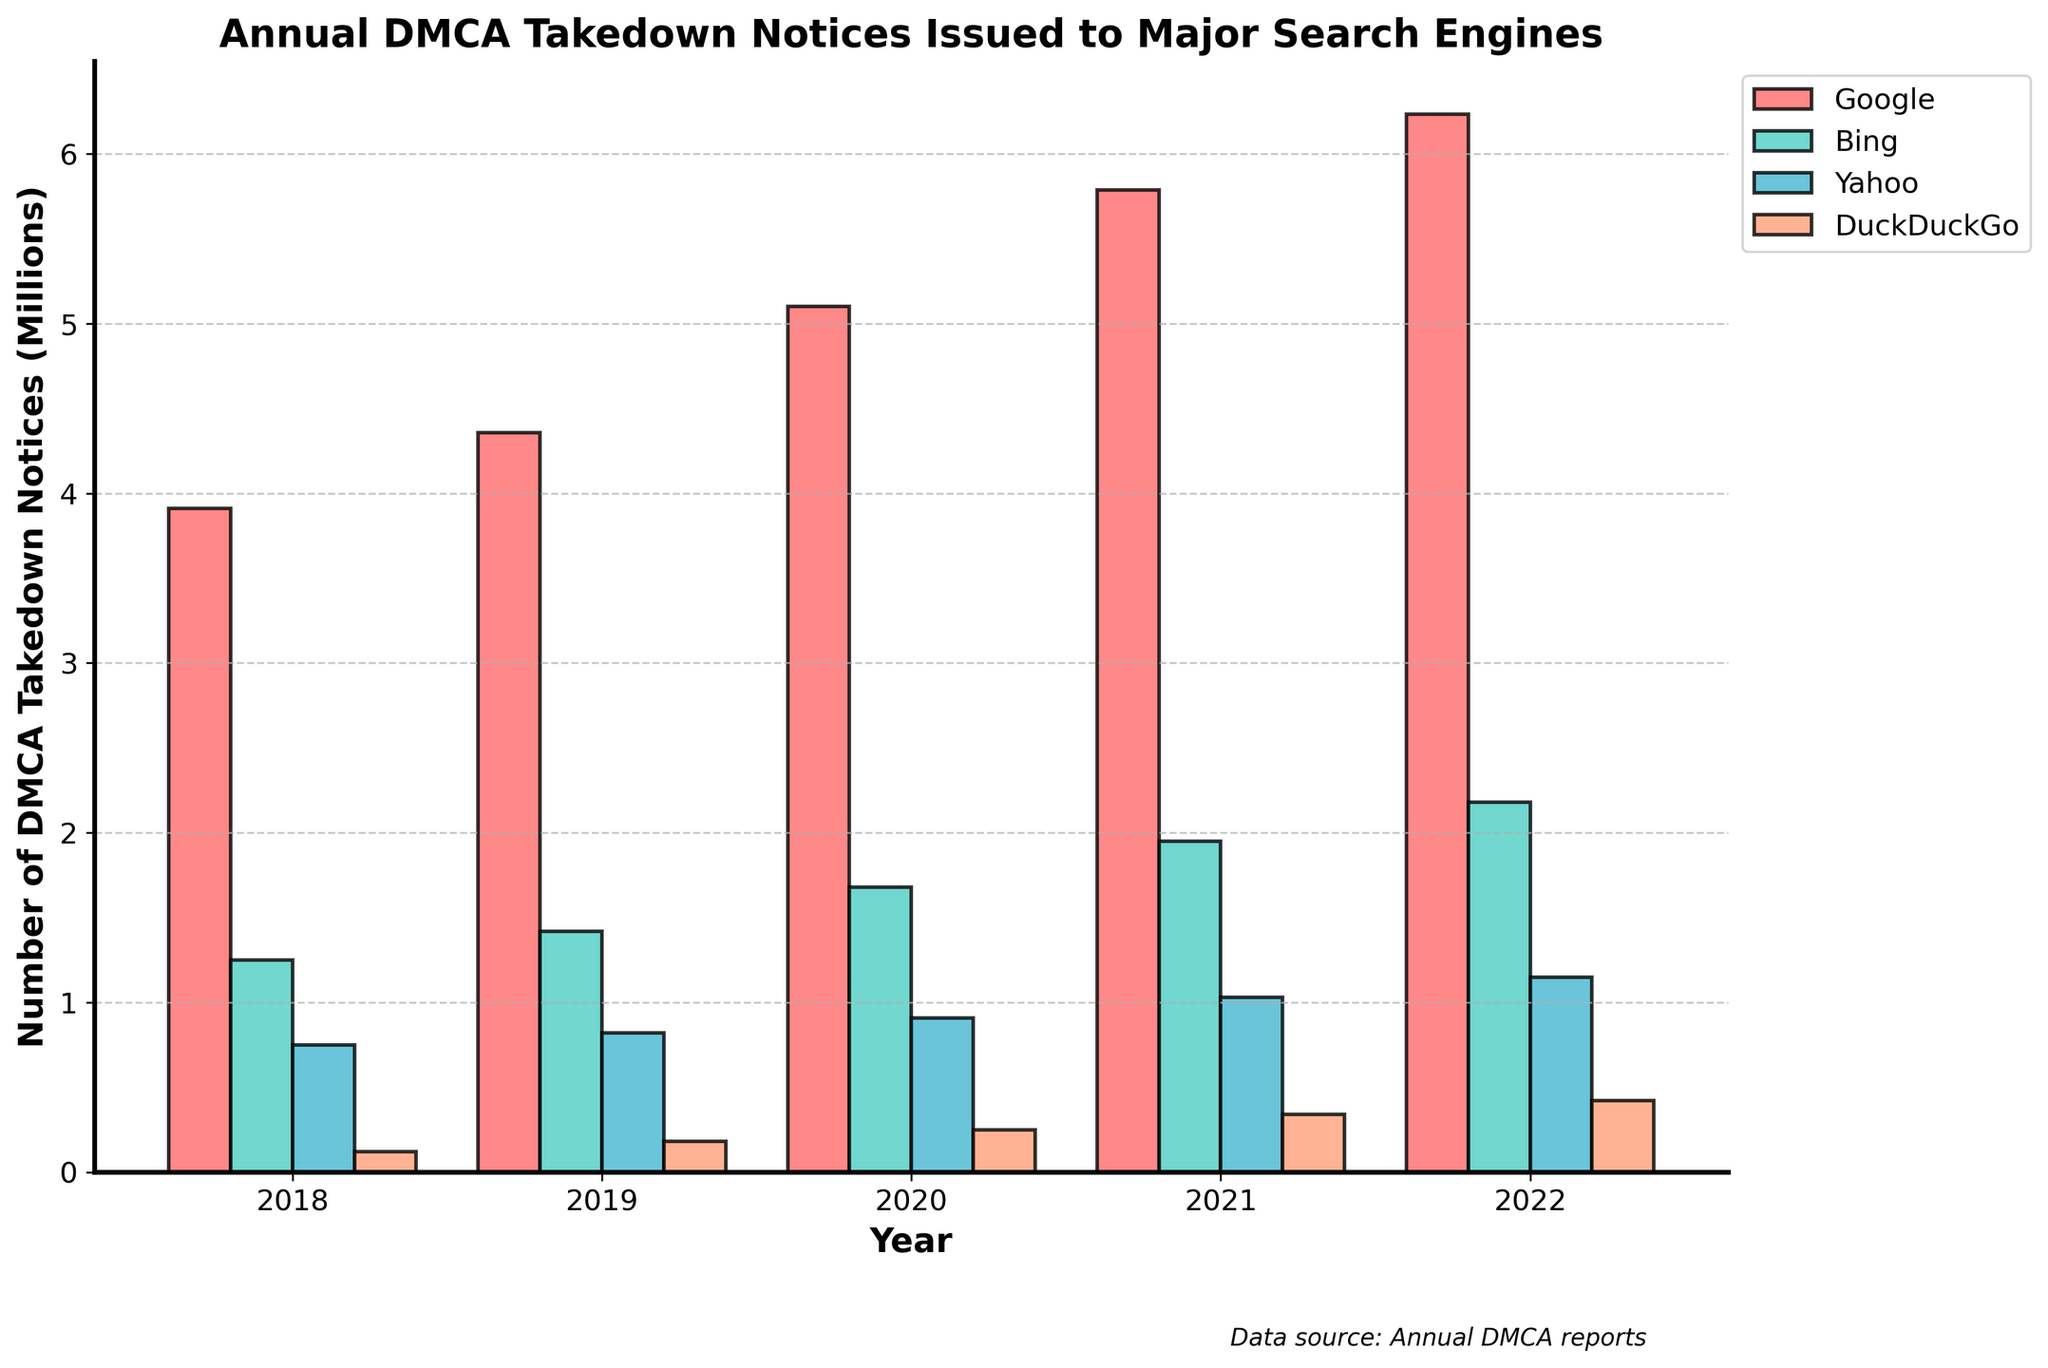How many DMCA takedown notices were issued to Google in 2021? Look for the bar that represents Google for the year 2021 and read the value on the y-axis.
Answer: 5789000 Which search engine received the least DMCA takedown notices in 2020? Compare the heights of the bars for all the search engines in 2020; the shortest one corresponds to DuckDuckGo.
Answer: DuckDuckGo What is the difference between the number of DMCA takedown notices issued to Yahoo and DuckDuckGo in 2022? Subtract the number of DMCA takedown notices issued to DuckDuckGo from those issued to Yahoo for the year 2022 (1150000 - 420000).
Answer: 730000 Which year showed the highest number of DMCA takedown notices issued to Bing, and how many were issued? Look for the tallest bar representing Bing; the year is 2022 with a value of 2180000 notices.
Answer: 2022, 2180000 What is the total number of DMCA takedown notices issued to all search engines in 2019? Sum the values for all the search engines in 2019 (4356000 + 1420000 + 820000 + 180000).
Answer: 6776000 By how much did the number of DMCA takedown notices issued to DuckDuckGo increase from 2018 to 2022? Subtract the number of notices issued in 2018 from those issued in 2022 (420000 - 120000).
Answer: 300000 Which search engine showed the largest increase in DMCA takedown notices from 2018 to 2022, and what is the value of that increase? Calculate the difference for each search engine between 2018 and 2022 and identify the largest (Google: 6234000 - 3912000, Bing: 2180000 - 1250000, Yahoo: 1150000 - 750000, DuckDuckGo: 420000 - 120000).
Answer: Google, 2322000 How many more DMCA takedown notices were issued to Google than to Bing in 2020? Subtract the number of notices for Bing from those for Google in 2020 (5102000 - 1680000).
Answer: 3422000 On average, how many DMCA takedown notices were issued to Yahoo annually from 2018 to 2022? Sum the annual values for Yahoo and divide by the number of years (five): (750000 + 820000 + 910000 + 1030000 + 1150000) / 5.
Answer: 932000 What trend can be observed for the number of DMCA takedown notices issued to DuckDuckGo from 2018 to 2022? Look at the height of DuckDuckGo's bars over the years; the numbers show a consistent annual increase.
Answer: Increasing consistently 